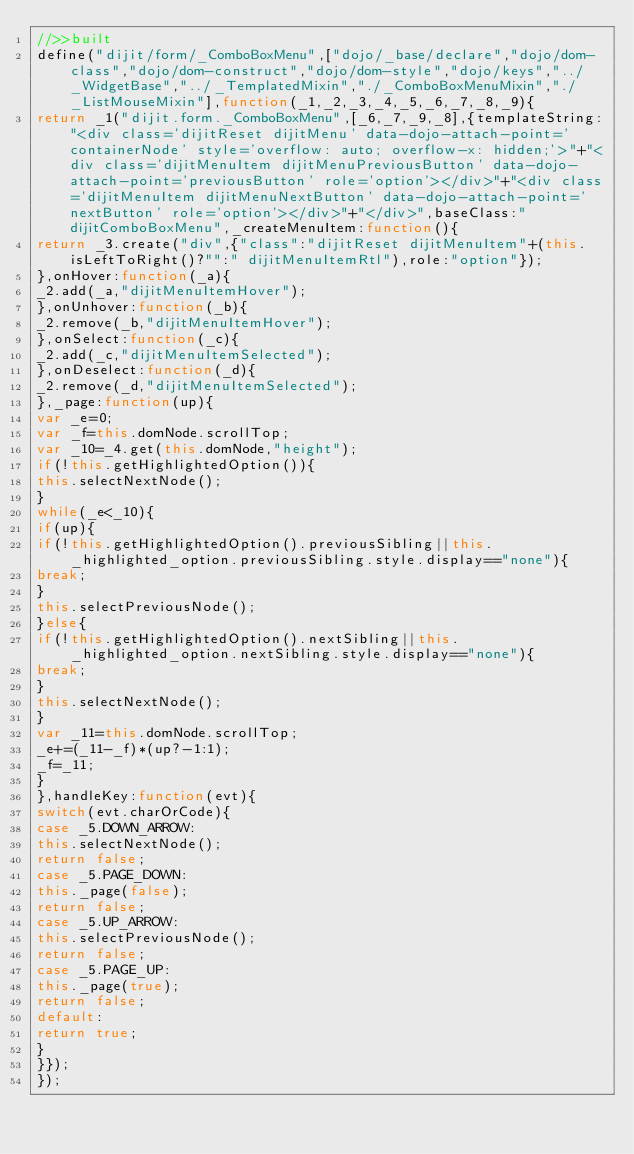Convert code to text. <code><loc_0><loc_0><loc_500><loc_500><_JavaScript_>//>>built
define("dijit/form/_ComboBoxMenu",["dojo/_base/declare","dojo/dom-class","dojo/dom-construct","dojo/dom-style","dojo/keys","../_WidgetBase","../_TemplatedMixin","./_ComboBoxMenuMixin","./_ListMouseMixin"],function(_1,_2,_3,_4,_5,_6,_7,_8,_9){
return _1("dijit.form._ComboBoxMenu",[_6,_7,_9,_8],{templateString:"<div class='dijitReset dijitMenu' data-dojo-attach-point='containerNode' style='overflow: auto; overflow-x: hidden;'>"+"<div class='dijitMenuItem dijitMenuPreviousButton' data-dojo-attach-point='previousButton' role='option'></div>"+"<div class='dijitMenuItem dijitMenuNextButton' data-dojo-attach-point='nextButton' role='option'></div>"+"</div>",baseClass:"dijitComboBoxMenu",_createMenuItem:function(){
return _3.create("div",{"class":"dijitReset dijitMenuItem"+(this.isLeftToRight()?"":" dijitMenuItemRtl"),role:"option"});
},onHover:function(_a){
_2.add(_a,"dijitMenuItemHover");
},onUnhover:function(_b){
_2.remove(_b,"dijitMenuItemHover");
},onSelect:function(_c){
_2.add(_c,"dijitMenuItemSelected");
},onDeselect:function(_d){
_2.remove(_d,"dijitMenuItemSelected");
},_page:function(up){
var _e=0;
var _f=this.domNode.scrollTop;
var _10=_4.get(this.domNode,"height");
if(!this.getHighlightedOption()){
this.selectNextNode();
}
while(_e<_10){
if(up){
if(!this.getHighlightedOption().previousSibling||this._highlighted_option.previousSibling.style.display=="none"){
break;
}
this.selectPreviousNode();
}else{
if(!this.getHighlightedOption().nextSibling||this._highlighted_option.nextSibling.style.display=="none"){
break;
}
this.selectNextNode();
}
var _11=this.domNode.scrollTop;
_e+=(_11-_f)*(up?-1:1);
_f=_11;
}
},handleKey:function(evt){
switch(evt.charOrCode){
case _5.DOWN_ARROW:
this.selectNextNode();
return false;
case _5.PAGE_DOWN:
this._page(false);
return false;
case _5.UP_ARROW:
this.selectPreviousNode();
return false;
case _5.PAGE_UP:
this._page(true);
return false;
default:
return true;
}
}});
});
 </code> 